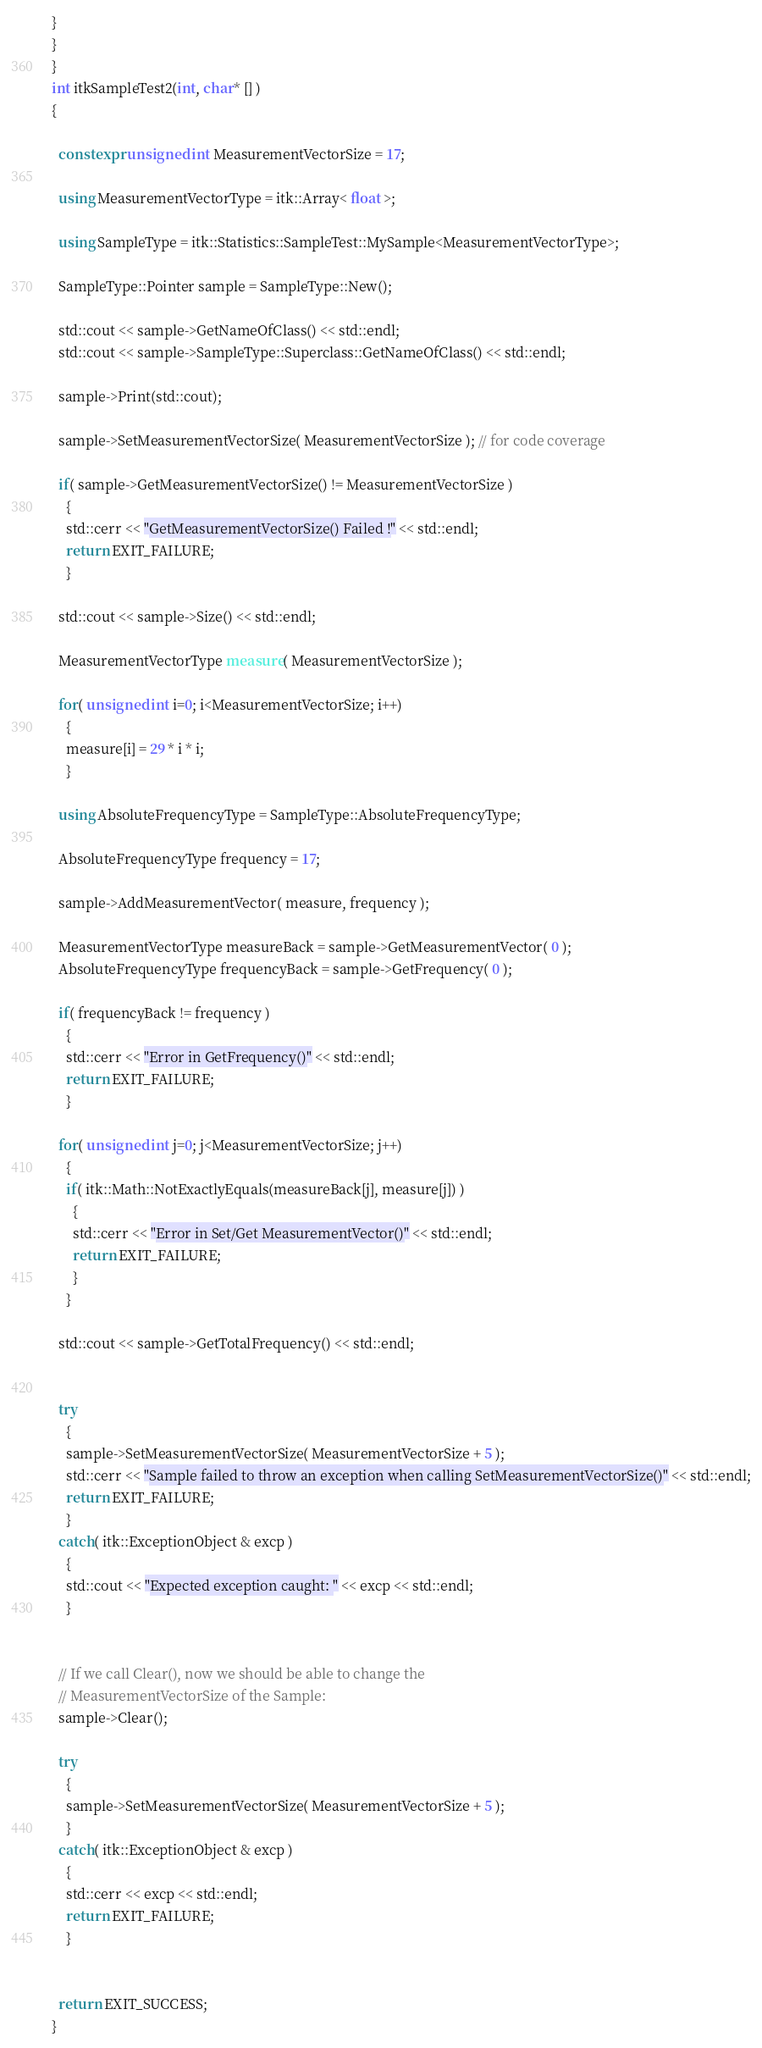<code> <loc_0><loc_0><loc_500><loc_500><_C++_>
}
}
}
int itkSampleTest2(int, char* [] )
{

  constexpr unsigned int MeasurementVectorSize = 17;

  using MeasurementVectorType = itk::Array< float >;

  using SampleType = itk::Statistics::SampleTest::MySample<MeasurementVectorType>;

  SampleType::Pointer sample = SampleType::New();

  std::cout << sample->GetNameOfClass() << std::endl;
  std::cout << sample->SampleType::Superclass::GetNameOfClass() << std::endl;

  sample->Print(std::cout);

  sample->SetMeasurementVectorSize( MeasurementVectorSize ); // for code coverage

  if( sample->GetMeasurementVectorSize() != MeasurementVectorSize )
    {
    std::cerr << "GetMeasurementVectorSize() Failed !" << std::endl;
    return EXIT_FAILURE;
    }

  std::cout << sample->Size() << std::endl;

  MeasurementVectorType measure( MeasurementVectorSize );

  for( unsigned int i=0; i<MeasurementVectorSize; i++)
    {
    measure[i] = 29 * i * i;
    }

  using AbsoluteFrequencyType = SampleType::AbsoluteFrequencyType;

  AbsoluteFrequencyType frequency = 17;

  sample->AddMeasurementVector( measure, frequency );

  MeasurementVectorType measureBack = sample->GetMeasurementVector( 0 );
  AbsoluteFrequencyType frequencyBack = sample->GetFrequency( 0 );

  if( frequencyBack != frequency )
    {
    std::cerr << "Error in GetFrequency()" << std::endl;
    return EXIT_FAILURE;
    }

  for( unsigned int j=0; j<MeasurementVectorSize; j++)
    {
    if( itk::Math::NotExactlyEquals(measureBack[j], measure[j]) )
      {
      std::cerr << "Error in Set/Get MeasurementVector()" << std::endl;
      return EXIT_FAILURE;
      }
    }

  std::cout << sample->GetTotalFrequency() << std::endl;


  try
    {
    sample->SetMeasurementVectorSize( MeasurementVectorSize + 5 );
    std::cerr << "Sample failed to throw an exception when calling SetMeasurementVectorSize()" << std::endl;
    return EXIT_FAILURE;
    }
  catch( itk::ExceptionObject & excp )
    {
    std::cout << "Expected exception caught: " << excp << std::endl;
    }


  // If we call Clear(), now we should be able to change the
  // MeasurementVectorSize of the Sample:
  sample->Clear();

  try
    {
    sample->SetMeasurementVectorSize( MeasurementVectorSize + 5 );
    }
  catch( itk::ExceptionObject & excp )
    {
    std::cerr << excp << std::endl;
    return EXIT_FAILURE;
    }


  return EXIT_SUCCESS;
}
</code> 